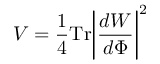<formula> <loc_0><loc_0><loc_500><loc_500>V = { \frac { 1 } { 4 } } T r \left | { \frac { d W } { d \Phi } } \right | ^ { 2 }</formula> 